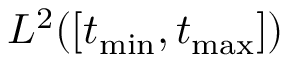Convert formula to latex. <formula><loc_0><loc_0><loc_500><loc_500>L ^ { 2 } ( [ t _ { \min } , t _ { \max } ] )</formula> 